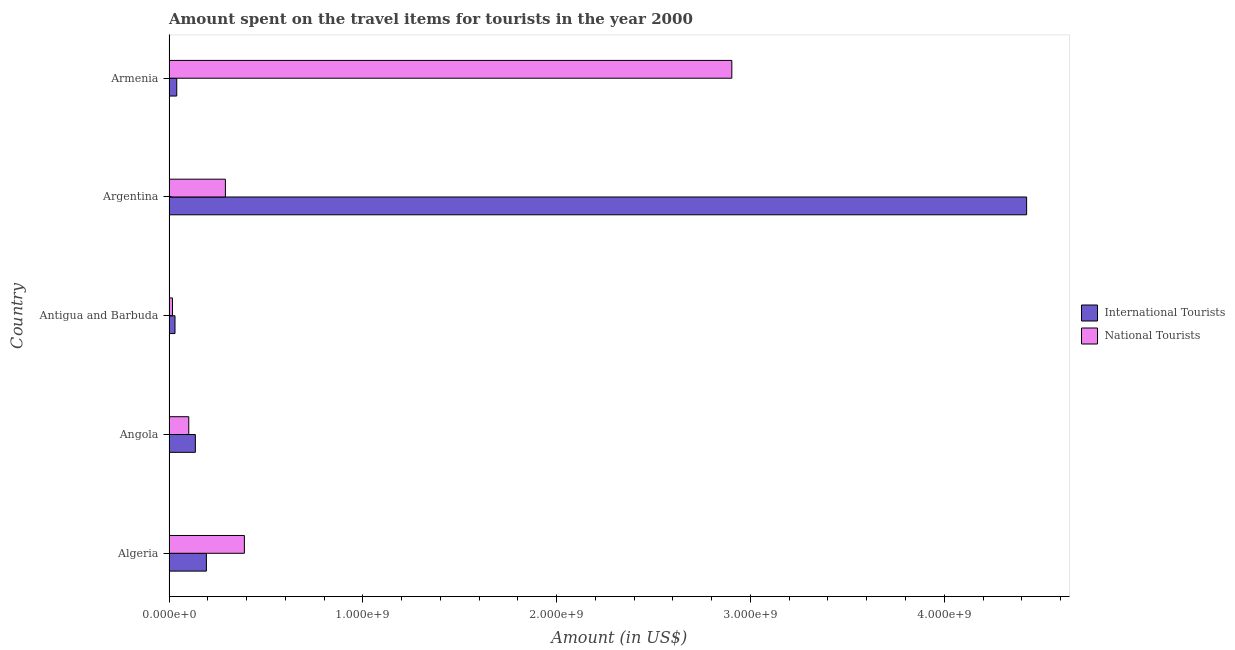How many groups of bars are there?
Provide a succinct answer. 5. Are the number of bars on each tick of the Y-axis equal?
Make the answer very short. Yes. How many bars are there on the 2nd tick from the bottom?
Keep it short and to the point. 2. What is the label of the 5th group of bars from the top?
Ensure brevity in your answer.  Algeria. What is the amount spent on travel items of international tourists in Algeria?
Give a very brief answer. 1.93e+08. Across all countries, what is the maximum amount spent on travel items of national tourists?
Make the answer very short. 2.90e+09. Across all countries, what is the minimum amount spent on travel items of international tourists?
Offer a very short reply. 3.10e+07. In which country was the amount spent on travel items of national tourists maximum?
Your answer should be compact. Armenia. In which country was the amount spent on travel items of international tourists minimum?
Make the answer very short. Antigua and Barbuda. What is the total amount spent on travel items of national tourists in the graph?
Offer a terse response. 3.70e+09. What is the difference between the amount spent on travel items of national tourists in Algeria and that in Antigua and Barbuda?
Your response must be concise. 3.71e+08. What is the difference between the amount spent on travel items of international tourists in Argentina and the amount spent on travel items of national tourists in Algeria?
Provide a short and direct response. 4.04e+09. What is the average amount spent on travel items of international tourists per country?
Offer a very short reply. 9.65e+08. What is the difference between the amount spent on travel items of international tourists and amount spent on travel items of national tourists in Armenia?
Give a very brief answer. -2.86e+09. What is the ratio of the amount spent on travel items of international tourists in Angola to that in Argentina?
Offer a terse response. 0.03. What is the difference between the highest and the second highest amount spent on travel items of national tourists?
Make the answer very short. 2.52e+09. What is the difference between the highest and the lowest amount spent on travel items of international tourists?
Keep it short and to the point. 4.39e+09. In how many countries, is the amount spent on travel items of international tourists greater than the average amount spent on travel items of international tourists taken over all countries?
Your response must be concise. 1. What does the 2nd bar from the top in Armenia represents?
Offer a terse response. International Tourists. What does the 2nd bar from the bottom in Argentina represents?
Offer a terse response. National Tourists. Are all the bars in the graph horizontal?
Your answer should be compact. Yes. What is the difference between two consecutive major ticks on the X-axis?
Provide a short and direct response. 1.00e+09. What is the title of the graph?
Your response must be concise. Amount spent on the travel items for tourists in the year 2000. What is the label or title of the X-axis?
Your answer should be very brief. Amount (in US$). What is the label or title of the Y-axis?
Make the answer very short. Country. What is the Amount (in US$) in International Tourists in Algeria?
Keep it short and to the point. 1.93e+08. What is the Amount (in US$) in National Tourists in Algeria?
Offer a very short reply. 3.89e+08. What is the Amount (in US$) of International Tourists in Angola?
Offer a very short reply. 1.36e+08. What is the Amount (in US$) in National Tourists in Angola?
Offer a very short reply. 1.02e+08. What is the Amount (in US$) in International Tourists in Antigua and Barbuda?
Your answer should be very brief. 3.10e+07. What is the Amount (in US$) of National Tourists in Antigua and Barbuda?
Your answer should be compact. 1.80e+07. What is the Amount (in US$) in International Tourists in Argentina?
Make the answer very short. 4.42e+09. What is the Amount (in US$) in National Tourists in Argentina?
Give a very brief answer. 2.91e+08. What is the Amount (in US$) of International Tourists in Armenia?
Keep it short and to the point. 4.00e+07. What is the Amount (in US$) in National Tourists in Armenia?
Provide a succinct answer. 2.90e+09. Across all countries, what is the maximum Amount (in US$) of International Tourists?
Ensure brevity in your answer.  4.42e+09. Across all countries, what is the maximum Amount (in US$) of National Tourists?
Your response must be concise. 2.90e+09. Across all countries, what is the minimum Amount (in US$) of International Tourists?
Offer a terse response. 3.10e+07. Across all countries, what is the minimum Amount (in US$) of National Tourists?
Make the answer very short. 1.80e+07. What is the total Amount (in US$) in International Tourists in the graph?
Your answer should be compact. 4.82e+09. What is the total Amount (in US$) of National Tourists in the graph?
Provide a short and direct response. 3.70e+09. What is the difference between the Amount (in US$) of International Tourists in Algeria and that in Angola?
Give a very brief answer. 5.70e+07. What is the difference between the Amount (in US$) in National Tourists in Algeria and that in Angola?
Offer a terse response. 2.87e+08. What is the difference between the Amount (in US$) in International Tourists in Algeria and that in Antigua and Barbuda?
Your answer should be compact. 1.62e+08. What is the difference between the Amount (in US$) in National Tourists in Algeria and that in Antigua and Barbuda?
Your response must be concise. 3.71e+08. What is the difference between the Amount (in US$) of International Tourists in Algeria and that in Argentina?
Make the answer very short. -4.23e+09. What is the difference between the Amount (in US$) in National Tourists in Algeria and that in Argentina?
Offer a very short reply. 9.80e+07. What is the difference between the Amount (in US$) in International Tourists in Algeria and that in Armenia?
Provide a short and direct response. 1.53e+08. What is the difference between the Amount (in US$) in National Tourists in Algeria and that in Armenia?
Offer a very short reply. -2.52e+09. What is the difference between the Amount (in US$) in International Tourists in Angola and that in Antigua and Barbuda?
Keep it short and to the point. 1.05e+08. What is the difference between the Amount (in US$) of National Tourists in Angola and that in Antigua and Barbuda?
Provide a short and direct response. 8.40e+07. What is the difference between the Amount (in US$) of International Tourists in Angola and that in Argentina?
Offer a very short reply. -4.29e+09. What is the difference between the Amount (in US$) of National Tourists in Angola and that in Argentina?
Your response must be concise. -1.89e+08. What is the difference between the Amount (in US$) in International Tourists in Angola and that in Armenia?
Offer a terse response. 9.60e+07. What is the difference between the Amount (in US$) in National Tourists in Angola and that in Armenia?
Give a very brief answer. -2.80e+09. What is the difference between the Amount (in US$) in International Tourists in Antigua and Barbuda and that in Argentina?
Make the answer very short. -4.39e+09. What is the difference between the Amount (in US$) in National Tourists in Antigua and Barbuda and that in Argentina?
Keep it short and to the point. -2.73e+08. What is the difference between the Amount (in US$) in International Tourists in Antigua and Barbuda and that in Armenia?
Provide a short and direct response. -9.00e+06. What is the difference between the Amount (in US$) in National Tourists in Antigua and Barbuda and that in Armenia?
Provide a succinct answer. -2.89e+09. What is the difference between the Amount (in US$) of International Tourists in Argentina and that in Armenia?
Give a very brief answer. 4.38e+09. What is the difference between the Amount (in US$) in National Tourists in Argentina and that in Armenia?
Offer a terse response. -2.61e+09. What is the difference between the Amount (in US$) in International Tourists in Algeria and the Amount (in US$) in National Tourists in Angola?
Keep it short and to the point. 9.10e+07. What is the difference between the Amount (in US$) of International Tourists in Algeria and the Amount (in US$) of National Tourists in Antigua and Barbuda?
Your answer should be very brief. 1.75e+08. What is the difference between the Amount (in US$) of International Tourists in Algeria and the Amount (in US$) of National Tourists in Argentina?
Ensure brevity in your answer.  -9.80e+07. What is the difference between the Amount (in US$) of International Tourists in Algeria and the Amount (in US$) of National Tourists in Armenia?
Give a very brief answer. -2.71e+09. What is the difference between the Amount (in US$) in International Tourists in Angola and the Amount (in US$) in National Tourists in Antigua and Barbuda?
Offer a very short reply. 1.18e+08. What is the difference between the Amount (in US$) in International Tourists in Angola and the Amount (in US$) in National Tourists in Argentina?
Your answer should be very brief. -1.55e+08. What is the difference between the Amount (in US$) in International Tourists in Angola and the Amount (in US$) in National Tourists in Armenia?
Offer a very short reply. -2.77e+09. What is the difference between the Amount (in US$) of International Tourists in Antigua and Barbuda and the Amount (in US$) of National Tourists in Argentina?
Your answer should be very brief. -2.60e+08. What is the difference between the Amount (in US$) of International Tourists in Antigua and Barbuda and the Amount (in US$) of National Tourists in Armenia?
Provide a succinct answer. -2.87e+09. What is the difference between the Amount (in US$) in International Tourists in Argentina and the Amount (in US$) in National Tourists in Armenia?
Provide a short and direct response. 1.52e+09. What is the average Amount (in US$) in International Tourists per country?
Your answer should be compact. 9.65e+08. What is the average Amount (in US$) of National Tourists per country?
Provide a short and direct response. 7.41e+08. What is the difference between the Amount (in US$) of International Tourists and Amount (in US$) of National Tourists in Algeria?
Give a very brief answer. -1.96e+08. What is the difference between the Amount (in US$) of International Tourists and Amount (in US$) of National Tourists in Angola?
Keep it short and to the point. 3.40e+07. What is the difference between the Amount (in US$) in International Tourists and Amount (in US$) in National Tourists in Antigua and Barbuda?
Make the answer very short. 1.30e+07. What is the difference between the Amount (in US$) of International Tourists and Amount (in US$) of National Tourists in Argentina?
Your answer should be very brief. 4.13e+09. What is the difference between the Amount (in US$) of International Tourists and Amount (in US$) of National Tourists in Armenia?
Your response must be concise. -2.86e+09. What is the ratio of the Amount (in US$) of International Tourists in Algeria to that in Angola?
Offer a terse response. 1.42. What is the ratio of the Amount (in US$) of National Tourists in Algeria to that in Angola?
Your answer should be compact. 3.81. What is the ratio of the Amount (in US$) in International Tourists in Algeria to that in Antigua and Barbuda?
Make the answer very short. 6.23. What is the ratio of the Amount (in US$) of National Tourists in Algeria to that in Antigua and Barbuda?
Give a very brief answer. 21.61. What is the ratio of the Amount (in US$) of International Tourists in Algeria to that in Argentina?
Give a very brief answer. 0.04. What is the ratio of the Amount (in US$) in National Tourists in Algeria to that in Argentina?
Make the answer very short. 1.34. What is the ratio of the Amount (in US$) of International Tourists in Algeria to that in Armenia?
Offer a terse response. 4.83. What is the ratio of the Amount (in US$) of National Tourists in Algeria to that in Armenia?
Offer a terse response. 0.13. What is the ratio of the Amount (in US$) of International Tourists in Angola to that in Antigua and Barbuda?
Your answer should be very brief. 4.39. What is the ratio of the Amount (in US$) in National Tourists in Angola to that in Antigua and Barbuda?
Provide a succinct answer. 5.67. What is the ratio of the Amount (in US$) of International Tourists in Angola to that in Argentina?
Ensure brevity in your answer.  0.03. What is the ratio of the Amount (in US$) of National Tourists in Angola to that in Argentina?
Provide a short and direct response. 0.35. What is the ratio of the Amount (in US$) of International Tourists in Angola to that in Armenia?
Your answer should be very brief. 3.4. What is the ratio of the Amount (in US$) in National Tourists in Angola to that in Armenia?
Keep it short and to the point. 0.04. What is the ratio of the Amount (in US$) of International Tourists in Antigua and Barbuda to that in Argentina?
Your response must be concise. 0.01. What is the ratio of the Amount (in US$) of National Tourists in Antigua and Barbuda to that in Argentina?
Your answer should be very brief. 0.06. What is the ratio of the Amount (in US$) of International Tourists in Antigua and Barbuda to that in Armenia?
Your response must be concise. 0.78. What is the ratio of the Amount (in US$) of National Tourists in Antigua and Barbuda to that in Armenia?
Ensure brevity in your answer.  0.01. What is the ratio of the Amount (in US$) in International Tourists in Argentina to that in Armenia?
Provide a short and direct response. 110.62. What is the ratio of the Amount (in US$) in National Tourists in Argentina to that in Armenia?
Your answer should be very brief. 0.1. What is the difference between the highest and the second highest Amount (in US$) in International Tourists?
Your answer should be compact. 4.23e+09. What is the difference between the highest and the second highest Amount (in US$) in National Tourists?
Keep it short and to the point. 2.52e+09. What is the difference between the highest and the lowest Amount (in US$) of International Tourists?
Ensure brevity in your answer.  4.39e+09. What is the difference between the highest and the lowest Amount (in US$) in National Tourists?
Your answer should be compact. 2.89e+09. 